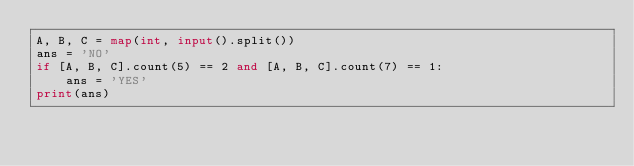Convert code to text. <code><loc_0><loc_0><loc_500><loc_500><_Python_>A, B, C = map(int, input().split())
ans = 'NO'
if [A, B, C].count(5) == 2 and [A, B, C].count(7) == 1:
    ans = 'YES'
print(ans)</code> 